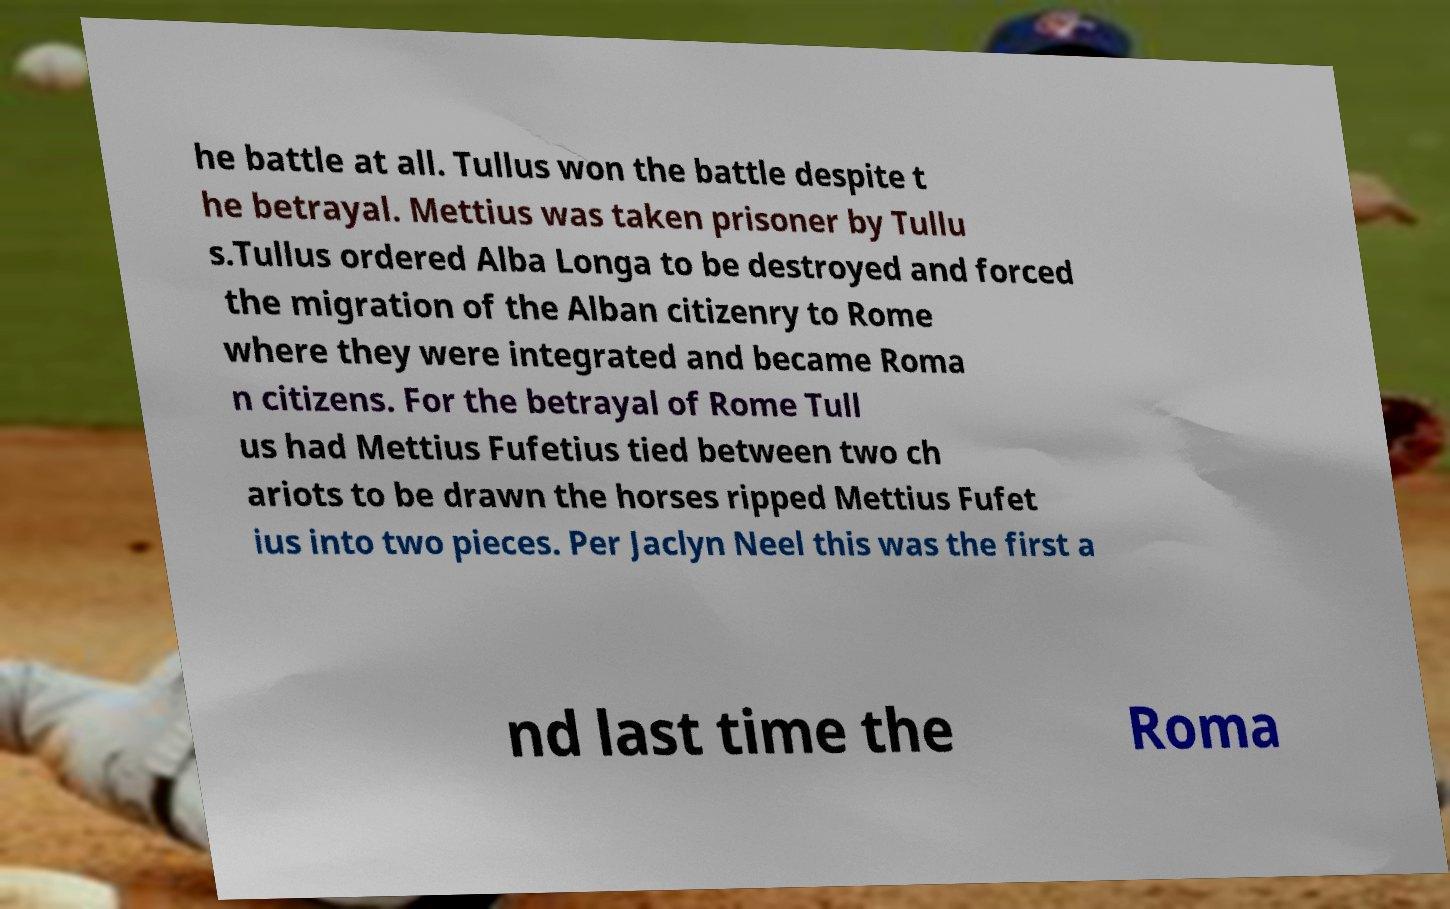Could you extract and type out the text from this image? he battle at all. Tullus won the battle despite t he betrayal. Mettius was taken prisoner by Tullu s.Tullus ordered Alba Longa to be destroyed and forced the migration of the Alban citizenry to Rome where they were integrated and became Roma n citizens. For the betrayal of Rome Tull us had Mettius Fufetius tied between two ch ariots to be drawn the horses ripped Mettius Fufet ius into two pieces. Per Jaclyn Neel this was the first a nd last time the Roma 